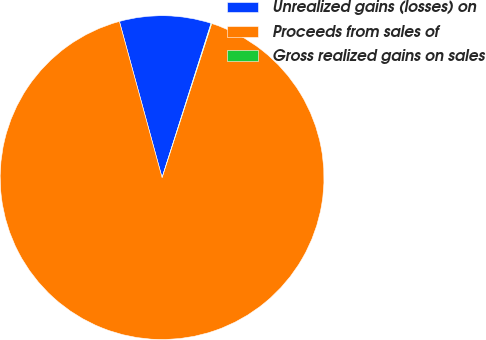Convert chart. <chart><loc_0><loc_0><loc_500><loc_500><pie_chart><fcel>Unrealized gains (losses) on<fcel>Proceeds from sales of<fcel>Gross realized gains on sales<nl><fcel>9.14%<fcel>90.8%<fcel>0.06%<nl></chart> 